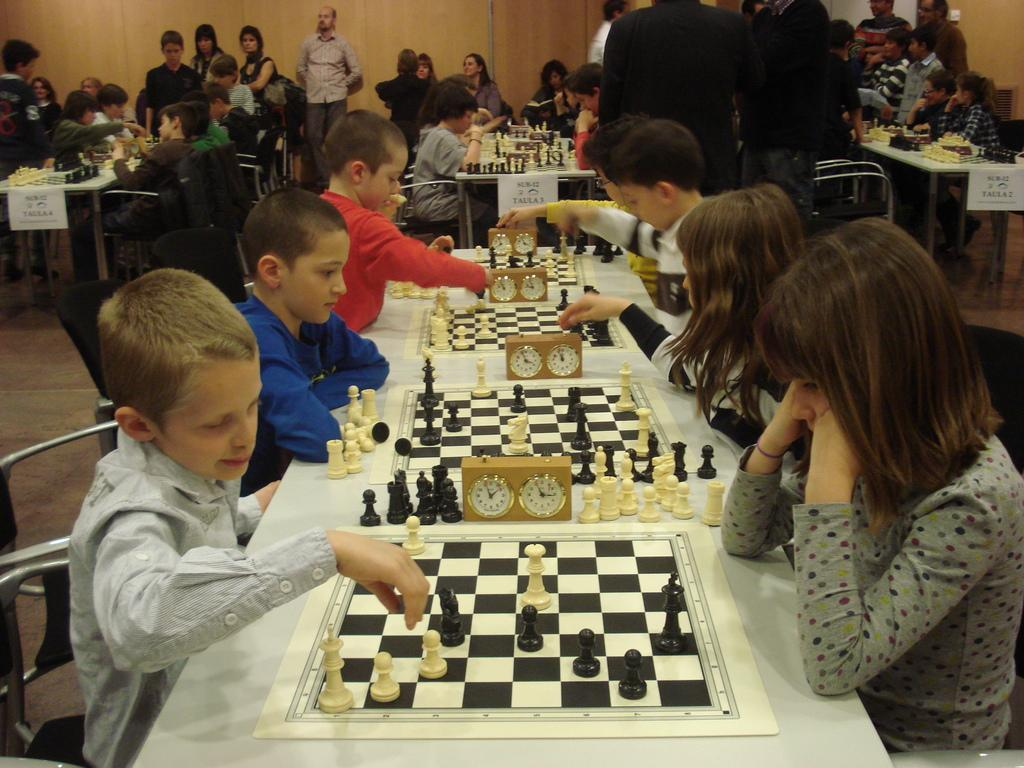What game is being played on the table in the image? Kids are playing chess on the table in the image. What items are present on the table that are related to the game? There are chess boards and chess clocks on the table. What are the kids sitting on while playing chess? The kids are sitting on chairs. Are there any other people visible in the image besides the kids playing chess? Yes, there are people standing in the image. Can you see a ladybug crawling on the chess board in the image? No, there is no ladybug present on the chess board in the image. 